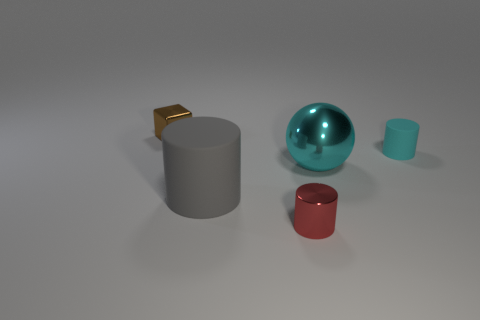How big is the cyan cylinder?
Your response must be concise. Small. What number of cyan things are either small blocks or small matte blocks?
Your answer should be very brief. 0. There is a rubber thing that is in front of the rubber cylinder that is to the right of the tiny object in front of the cyan shiny sphere; what size is it?
Give a very brief answer. Large. What size is the other matte object that is the same shape as the tiny cyan rubber thing?
Offer a very short reply. Large. What number of small objects are either matte cylinders or brown metal objects?
Keep it short and to the point. 2. Do the large object that is right of the gray thing and the small cylinder in front of the cyan metallic thing have the same material?
Offer a terse response. Yes. What is the thing that is to the right of the big cyan shiny ball made of?
Your response must be concise. Rubber. How many metallic things are large cyan things or big things?
Your answer should be very brief. 1. The metallic object that is on the right side of the tiny metal thing that is in front of the small brown metal object is what color?
Give a very brief answer. Cyan. Is the small brown object made of the same material as the cylinder that is behind the big gray object?
Make the answer very short. No. 